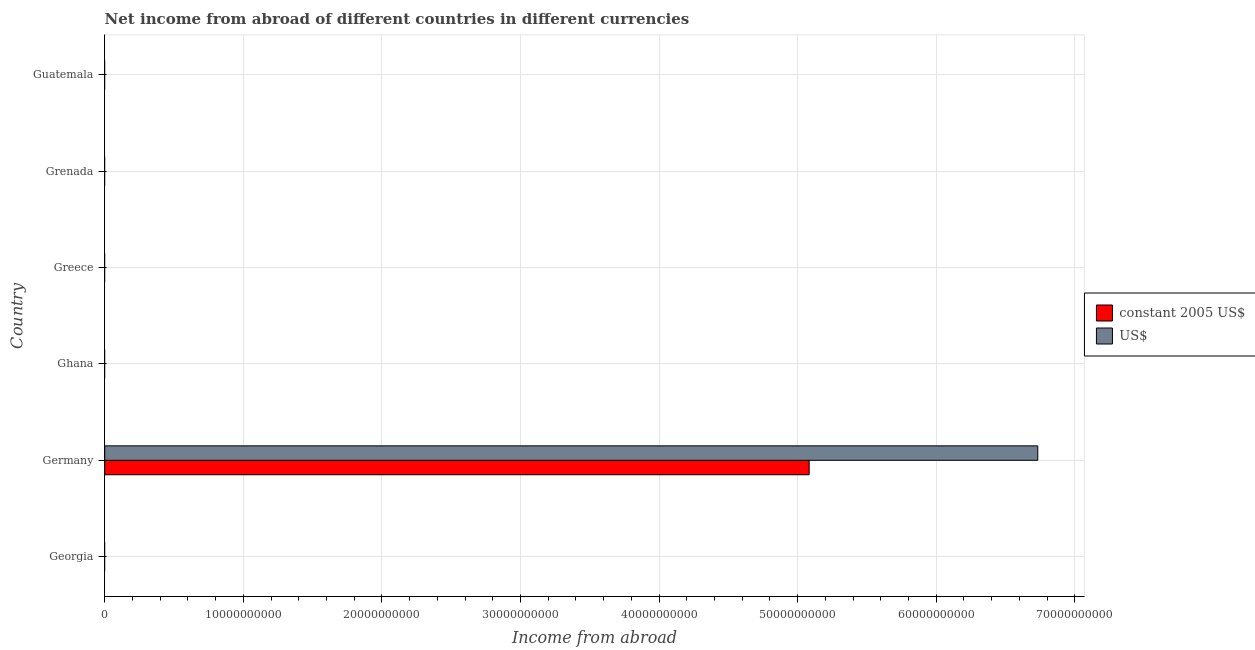Are the number of bars on each tick of the Y-axis equal?
Offer a very short reply. No. What is the label of the 1st group of bars from the top?
Make the answer very short. Guatemala. What is the income from abroad in constant 2005 us$ in Germany?
Provide a succinct answer. 5.08e+1. Across all countries, what is the maximum income from abroad in constant 2005 us$?
Offer a terse response. 5.08e+1. In which country was the income from abroad in constant 2005 us$ maximum?
Offer a terse response. Germany. What is the total income from abroad in constant 2005 us$ in the graph?
Your answer should be compact. 5.08e+1. What is the difference between the income from abroad in constant 2005 us$ in Guatemala and the income from abroad in us$ in Georgia?
Make the answer very short. 0. What is the average income from abroad in us$ per country?
Offer a very short reply. 1.12e+1. What is the difference between the income from abroad in us$ and income from abroad in constant 2005 us$ in Germany?
Offer a terse response. 1.65e+1. In how many countries, is the income from abroad in us$ greater than 66000000000 units?
Offer a terse response. 1. What is the difference between the highest and the lowest income from abroad in constant 2005 us$?
Keep it short and to the point. 5.08e+1. In how many countries, is the income from abroad in constant 2005 us$ greater than the average income from abroad in constant 2005 us$ taken over all countries?
Make the answer very short. 1. How many bars are there?
Make the answer very short. 2. Are all the bars in the graph horizontal?
Keep it short and to the point. Yes. What is the difference between two consecutive major ticks on the X-axis?
Offer a very short reply. 1.00e+1. Are the values on the major ticks of X-axis written in scientific E-notation?
Make the answer very short. No. What is the title of the graph?
Ensure brevity in your answer.  Net income from abroad of different countries in different currencies. What is the label or title of the X-axis?
Make the answer very short. Income from abroad. What is the Income from abroad of constant 2005 US$ in Georgia?
Offer a terse response. 0. What is the Income from abroad in US$ in Georgia?
Your answer should be compact. 0. What is the Income from abroad in constant 2005 US$ in Germany?
Provide a short and direct response. 5.08e+1. What is the Income from abroad of US$ in Germany?
Your response must be concise. 6.73e+1. What is the Income from abroad of constant 2005 US$ in Ghana?
Provide a short and direct response. 0. What is the Income from abroad in US$ in Ghana?
Your response must be concise. 0. What is the Income from abroad in constant 2005 US$ in Greece?
Keep it short and to the point. 0. What is the Income from abroad in constant 2005 US$ in Grenada?
Your response must be concise. 0. What is the Income from abroad of constant 2005 US$ in Guatemala?
Keep it short and to the point. 0. Across all countries, what is the maximum Income from abroad of constant 2005 US$?
Provide a succinct answer. 5.08e+1. Across all countries, what is the maximum Income from abroad of US$?
Offer a terse response. 6.73e+1. Across all countries, what is the minimum Income from abroad in US$?
Provide a short and direct response. 0. What is the total Income from abroad of constant 2005 US$ in the graph?
Offer a terse response. 5.08e+1. What is the total Income from abroad of US$ in the graph?
Your answer should be compact. 6.73e+1. What is the average Income from abroad of constant 2005 US$ per country?
Ensure brevity in your answer.  8.47e+09. What is the average Income from abroad of US$ per country?
Ensure brevity in your answer.  1.12e+1. What is the difference between the Income from abroad of constant 2005 US$ and Income from abroad of US$ in Germany?
Your answer should be compact. -1.65e+1. What is the difference between the highest and the lowest Income from abroad in constant 2005 US$?
Offer a terse response. 5.08e+1. What is the difference between the highest and the lowest Income from abroad in US$?
Offer a terse response. 6.73e+1. 